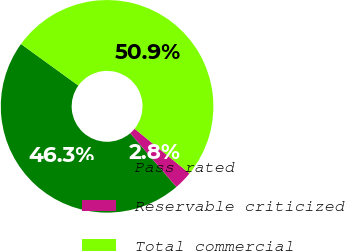Convert chart to OTSL. <chart><loc_0><loc_0><loc_500><loc_500><pie_chart><fcel>Pass rated<fcel>Reservable criticized<fcel>Total commercial<nl><fcel>46.27%<fcel>2.82%<fcel>50.9%<nl></chart> 